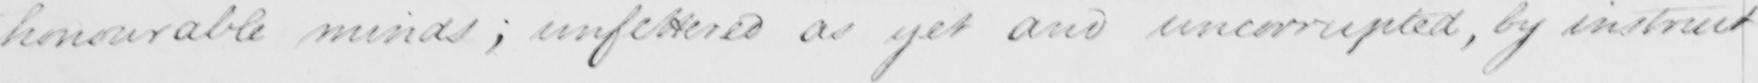Can you tell me what this handwritten text says? honourable minds ; unfettered as yet and uncorrupted , by instruct 